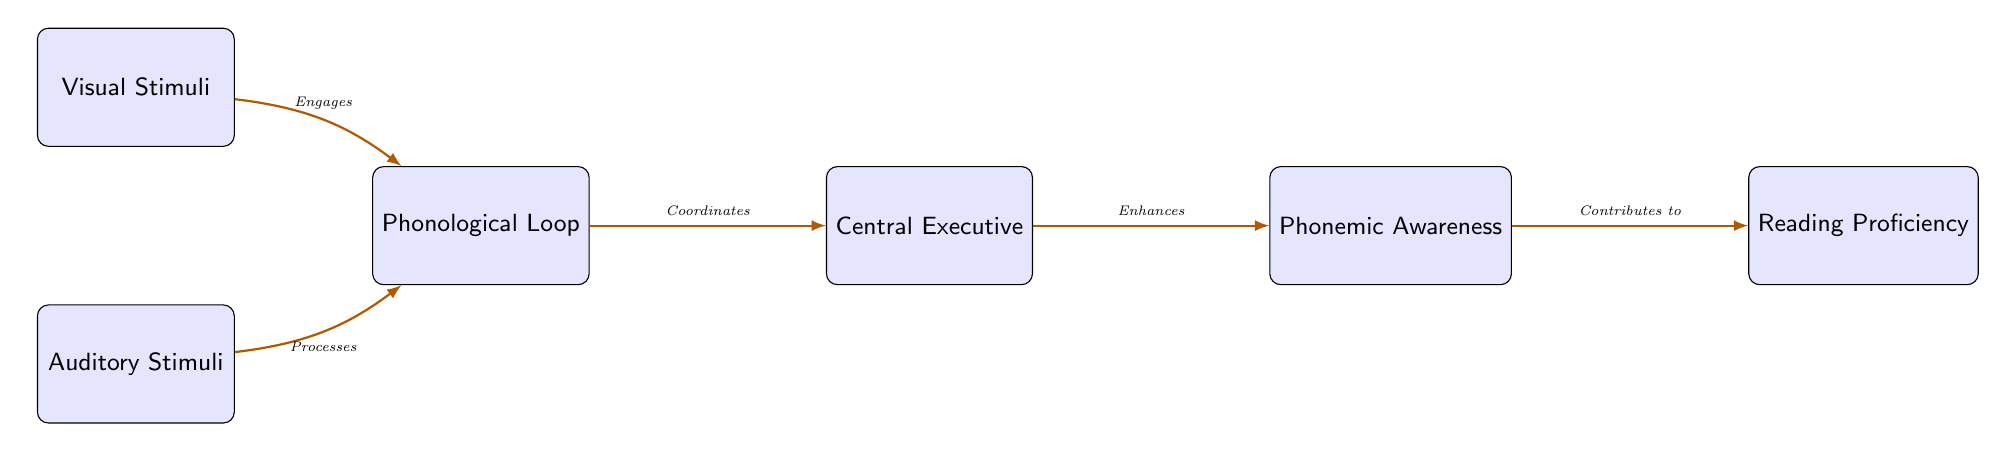What are the two types of stimuli in the diagram? The diagram lists two types of stimuli: Visual Stimuli and Auditory Stimuli, which are found as the first two nodes in order from top to bottom.
Answer: Visual Stimuli, Auditory Stimuli Which node comes after the Phonological Loop? The diagram shows that the node following the Phonological Loop is the Central Executive, as indicated by the rightward arrow connecting them.
Answer: Central Executive How many nodes are in the diagram? By counting the distinct rectangular nodes in the diagram, there are a total of six nodes represented.
Answer: 6 What relationship does the Central Executive have with Phonological Awareness? The diagram indicates that the Central Executive enhances Phonological Awareness, as represented by the directed arrow and label connecting these two nodes.
Answer: Enhances What do Visual Stimuli engage with in the diagram? The diagram shows that Visual Stimuli engage with the Phonological Loop, as indicated by an arrow directed from Visual Stimuli to the Phonological Loop.
Answer: Phonological Loop Which component contributes to Reading Proficiency? In the diagram, Phonemic Awareness is the component that contributes to Reading Proficiency, as indicated by the direct connection and flow towards Reading Proficiency.
Answer: Phonemic Awareness What is the direction of processing from Auditory Stimuli? The diagram shows that Auditory Stimuli process into the Phonological Loop, indicated by the directional arrow between these two nodes.
Answer: Phonological Loop What is the overall flow of information from Visual Stimuli to Reading Proficiency? The flow begins with Visual Stimuli engaging the Phonological Loop, which is coordinated by the Central Executive, leading to an enhancement of Phonemic Awareness, and finally contributing to Reading Proficiency. This series of relationships indicates a pathway of cognitive processing involved in literacy acquisition.
Answer: Visual Stimuli → Phonological Loop → Central Executive → Phonemic Awareness → Reading Proficiency 